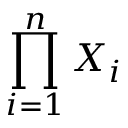Convert formula to latex. <formula><loc_0><loc_0><loc_500><loc_500>\prod _ { i = 1 } ^ { n } X _ { i }</formula> 